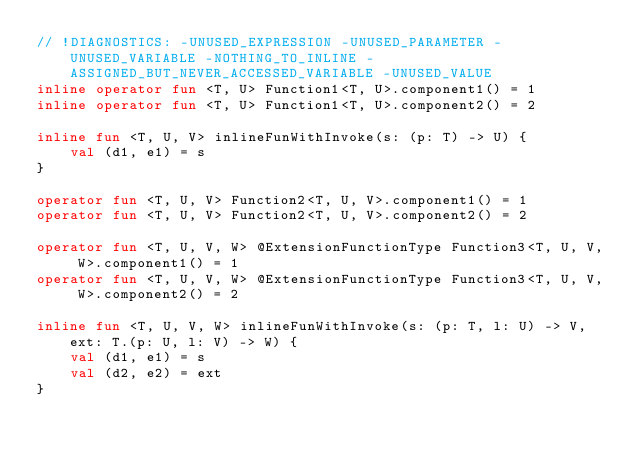Convert code to text. <code><loc_0><loc_0><loc_500><loc_500><_Kotlin_>// !DIAGNOSTICS: -UNUSED_EXPRESSION -UNUSED_PARAMETER -UNUSED_VARIABLE -NOTHING_TO_INLINE -ASSIGNED_BUT_NEVER_ACCESSED_VARIABLE -UNUSED_VALUE
inline operator fun <T, U> Function1<T, U>.component1() = 1
inline operator fun <T, U> Function1<T, U>.component2() = 2

inline fun <T, U, V> inlineFunWithInvoke(s: (p: T) -> U) {
    val (d1, e1) = s
}

operator fun <T, U, V> Function2<T, U, V>.component1() = 1
operator fun <T, U, V> Function2<T, U, V>.component2() = 2

operator fun <T, U, V, W> @ExtensionFunctionType Function3<T, U, V, W>.component1() = 1
operator fun <T, U, V, W> @ExtensionFunctionType Function3<T, U, V, W>.component2() = 2

inline fun <T, U, V, W> inlineFunWithInvoke(s: (p: T, l: U) -> V, ext: T.(p: U, l: V) -> W) {
    val (d1, e1) = s
    val (d2, e2) = ext
}
</code> 